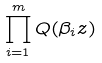<formula> <loc_0><loc_0><loc_500><loc_500>\prod _ { i = 1 } ^ { m } Q ( \beta _ { i } z )</formula> 